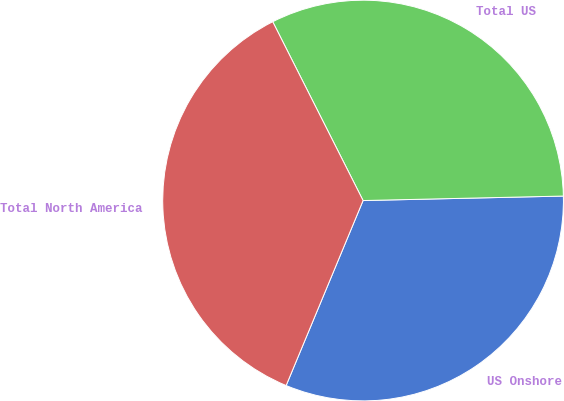Convert chart. <chart><loc_0><loc_0><loc_500><loc_500><pie_chart><fcel>US Onshore<fcel>Total US<fcel>Total North America<nl><fcel>31.63%<fcel>32.09%<fcel>36.28%<nl></chart> 